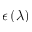Convert formula to latex. <formula><loc_0><loc_0><loc_500><loc_500>\epsilon \left ( \lambda \right )</formula> 